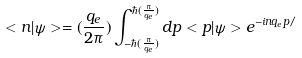Convert formula to latex. <formula><loc_0><loc_0><loc_500><loc_500>< n | \psi > = ( \frac { q _ { e } } { 2 \pi } ) \int ^ { \hbar { ( } \frac { \pi } { q _ { e } } ) } _ { - \hbar { ( } \frac { \pi } { q _ { e } } ) } d p < p | \psi > e ^ { - i n q _ { e } p / }</formula> 